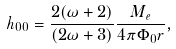Convert formula to latex. <formula><loc_0><loc_0><loc_500><loc_500>h _ { 0 0 } = \frac { 2 ( \omega + 2 ) } { ( 2 \omega + 3 ) } \frac { M _ { e } } { 4 \pi \Phi _ { 0 } r } ,</formula> 